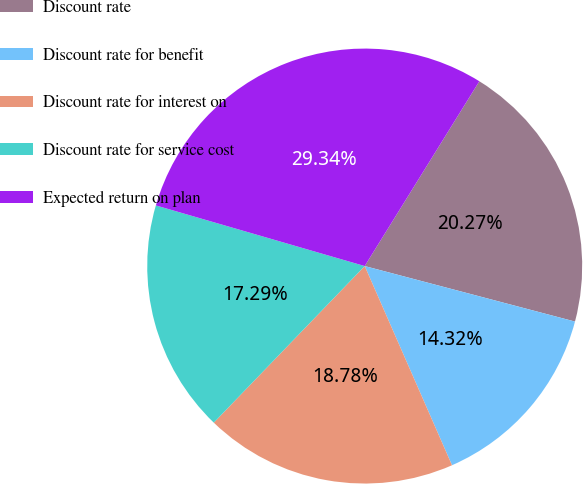Convert chart to OTSL. <chart><loc_0><loc_0><loc_500><loc_500><pie_chart><fcel>Discount rate<fcel>Discount rate for benefit<fcel>Discount rate for interest on<fcel>Discount rate for service cost<fcel>Expected return on plan<nl><fcel>20.27%<fcel>14.32%<fcel>18.78%<fcel>17.29%<fcel>29.34%<nl></chart> 